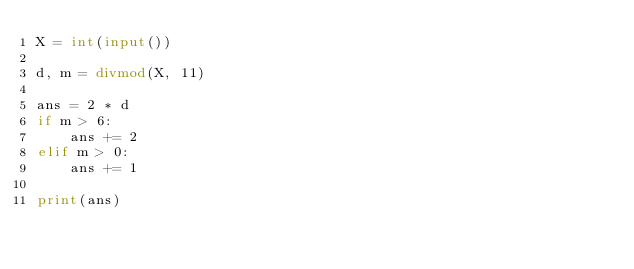<code> <loc_0><loc_0><loc_500><loc_500><_Python_>X = int(input())

d, m = divmod(X, 11)

ans = 2 * d
if m > 6:
    ans += 2
elif m > 0:
    ans += 1

print(ans)</code> 